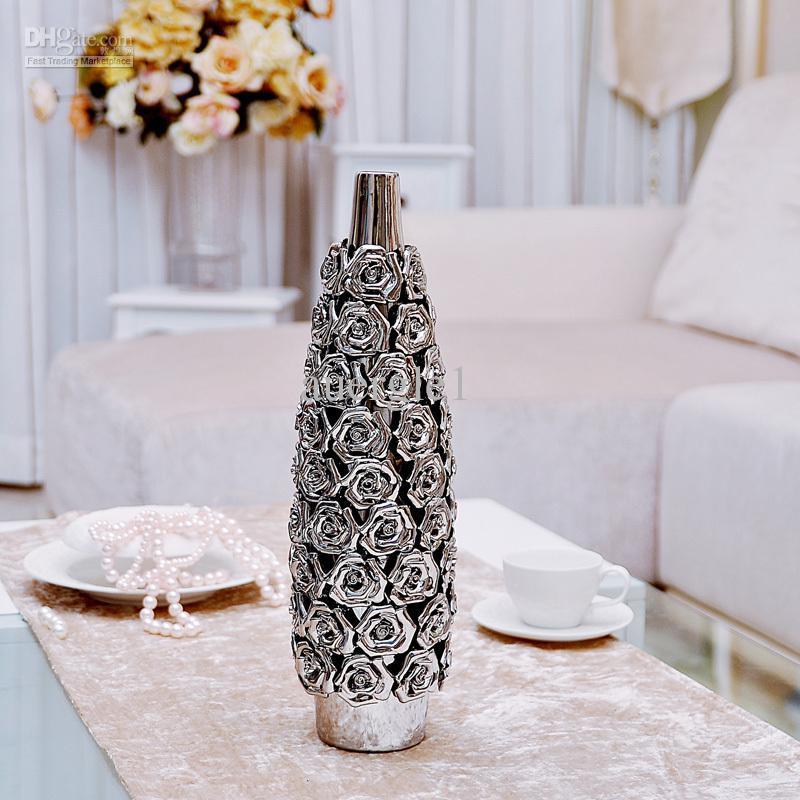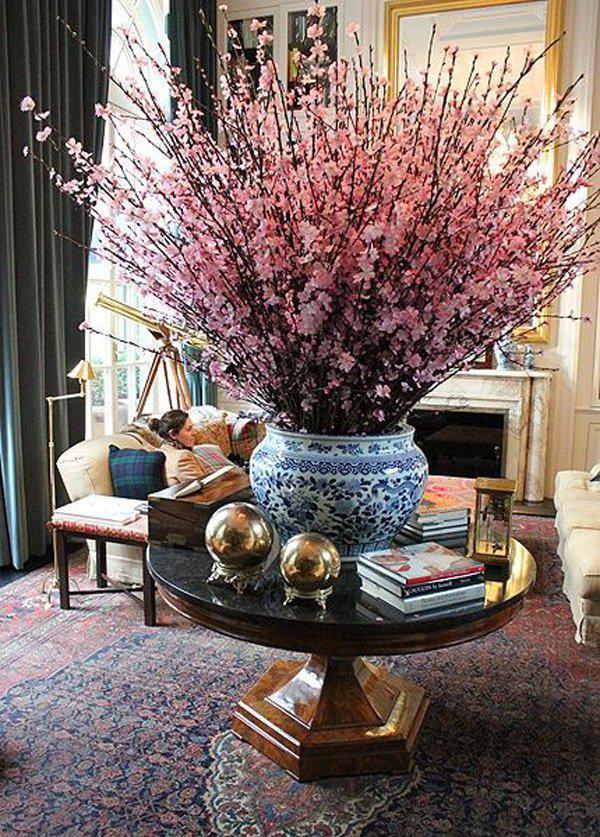The first image is the image on the left, the second image is the image on the right. Analyze the images presented: Is the assertion "Curtains are visible in the background of the image on the left." valid? Answer yes or no. Yes. 